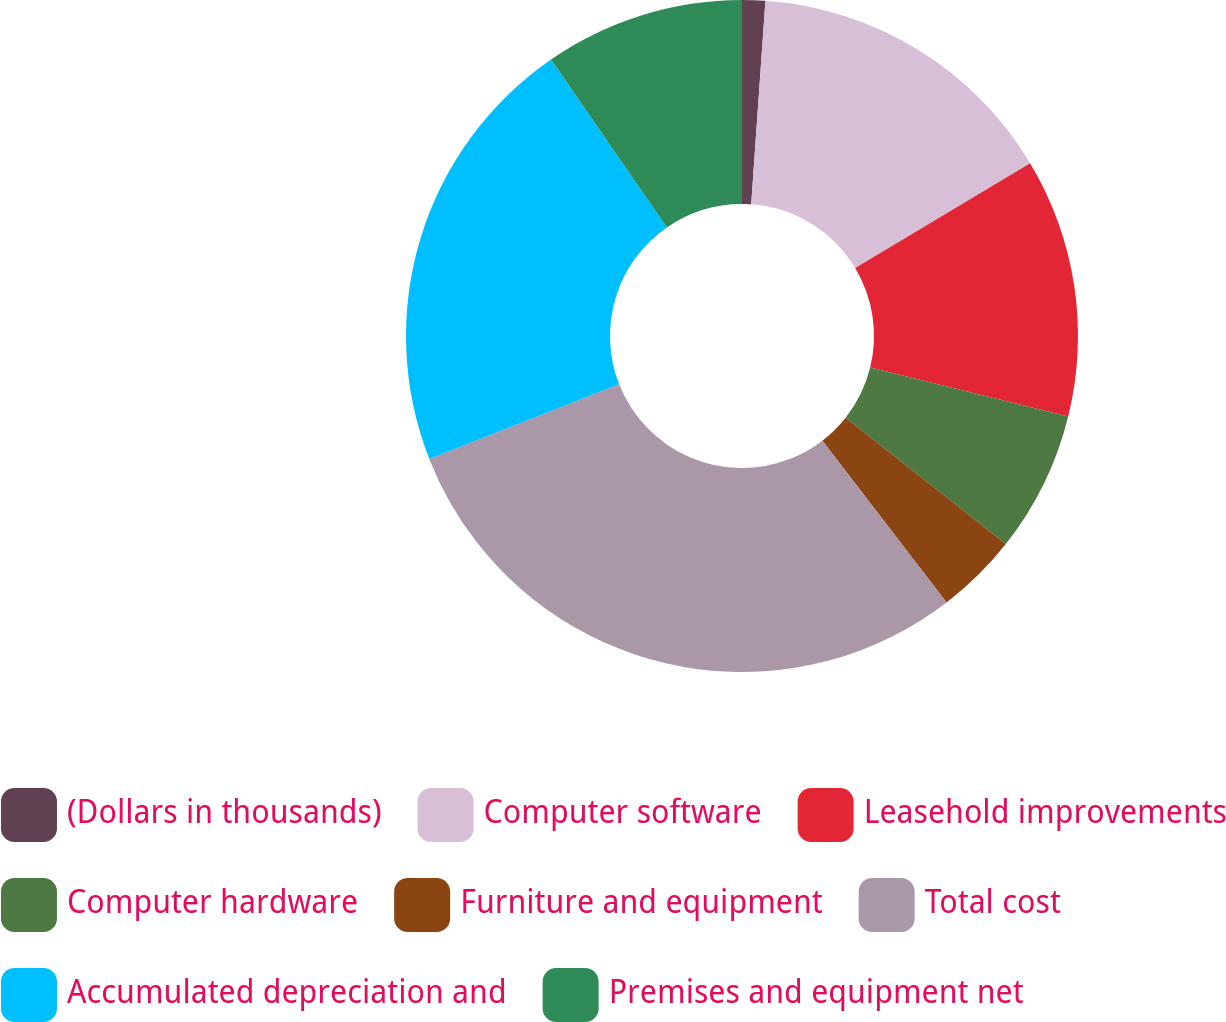Convert chart to OTSL. <chart><loc_0><loc_0><loc_500><loc_500><pie_chart><fcel>(Dollars in thousands)<fcel>Computer software<fcel>Leasehold improvements<fcel>Computer hardware<fcel>Furniture and equipment<fcel>Total cost<fcel>Accumulated depreciation and<fcel>Premises and equipment net<nl><fcel>1.11%<fcel>15.29%<fcel>12.45%<fcel>6.78%<fcel>3.95%<fcel>29.46%<fcel>21.34%<fcel>9.62%<nl></chart> 